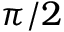Convert formula to latex. <formula><loc_0><loc_0><loc_500><loc_500>\pi / 2</formula> 